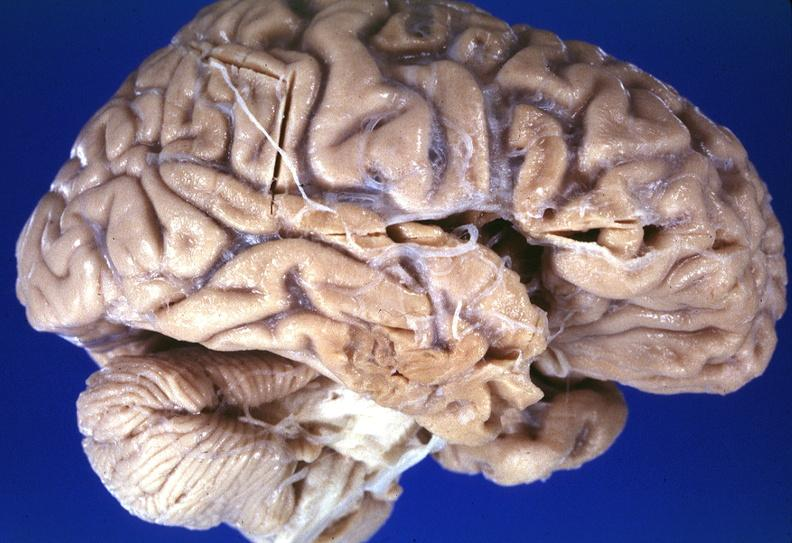what is present?
Answer the question using a single word or phrase. Nervous 